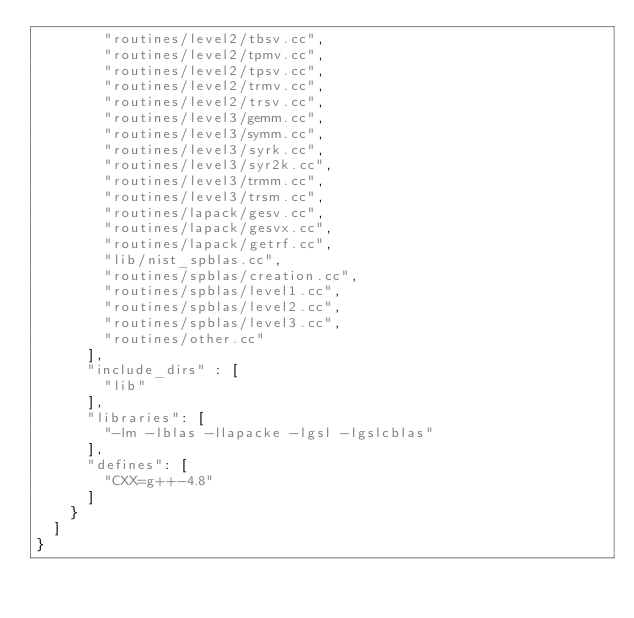<code> <loc_0><loc_0><loc_500><loc_500><_Python_>        "routines/level2/tbsv.cc",
        "routines/level2/tpmv.cc",
        "routines/level2/tpsv.cc",
        "routines/level2/trmv.cc",
        "routines/level2/trsv.cc",
        "routines/level3/gemm.cc",
        "routines/level3/symm.cc",
        "routines/level3/syrk.cc",
        "routines/level3/syr2k.cc",
        "routines/level3/trmm.cc",
        "routines/level3/trsm.cc",
        "routines/lapack/gesv.cc",
        "routines/lapack/gesvx.cc",
        "routines/lapack/getrf.cc",
        "lib/nist_spblas.cc",
        "routines/spblas/creation.cc",
        "routines/spblas/level1.cc",
        "routines/spblas/level2.cc",
        "routines/spblas/level3.cc",
        "routines/other.cc"
      ],
      "include_dirs" : [
        "lib"
      ],
      "libraries": [
        "-lm -lblas -llapacke -lgsl -lgslcblas"
      ],
      "defines": [
        "CXX=g++-4.8"
      ]
    }
  ]
}
</code> 